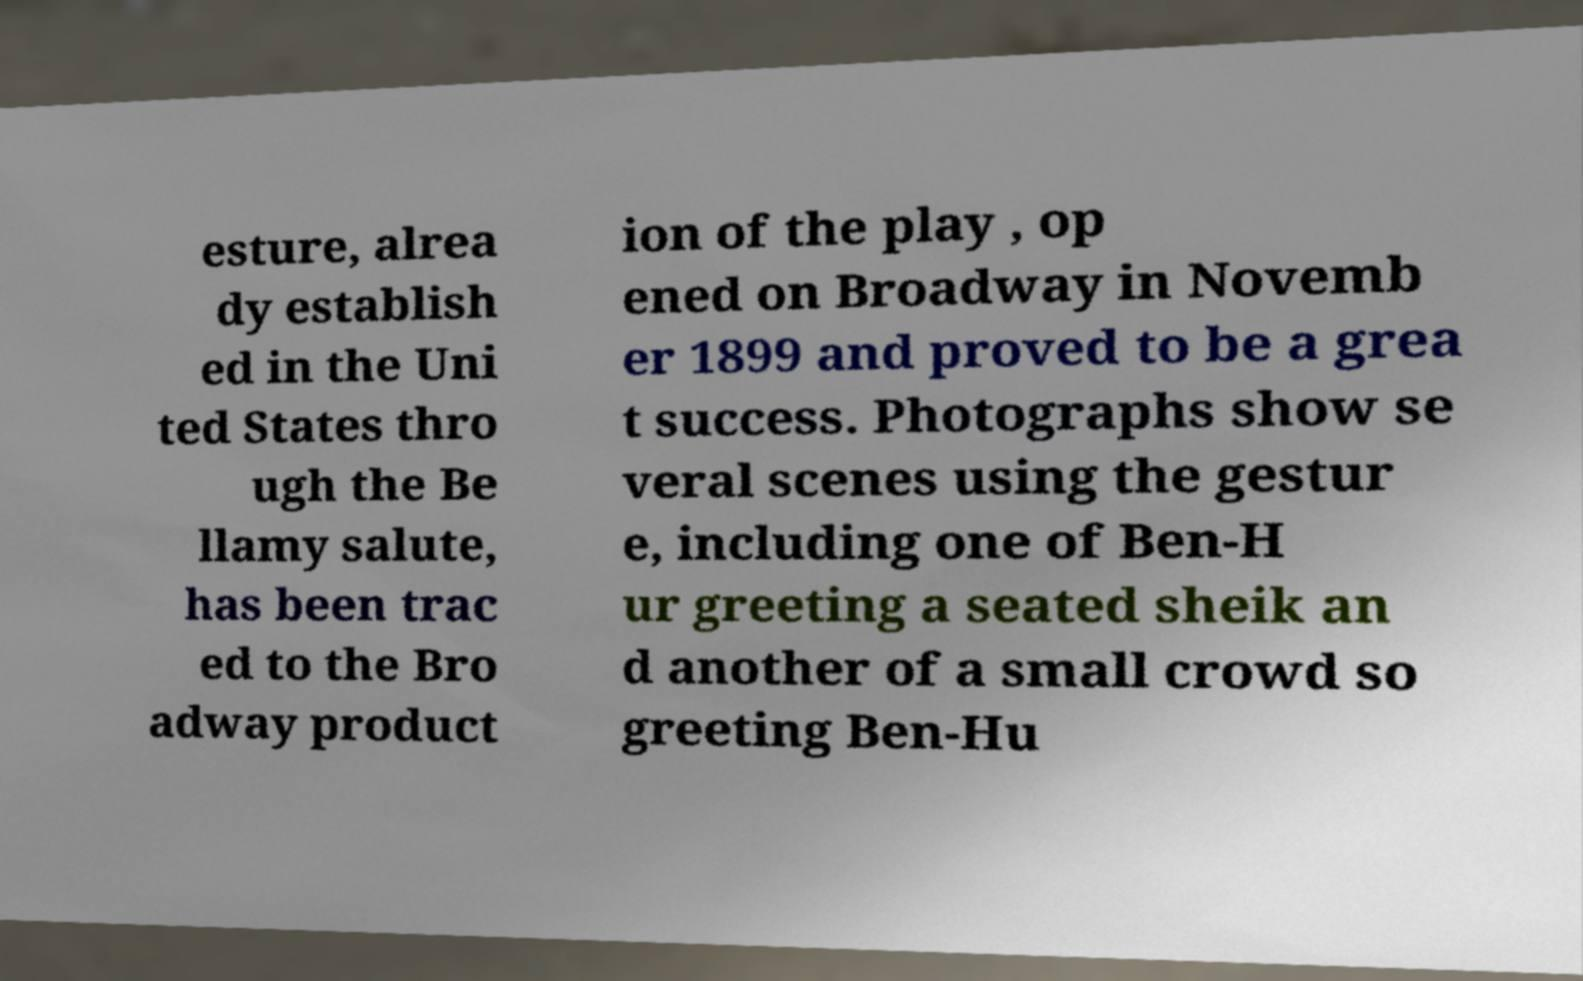What messages or text are displayed in this image? I need them in a readable, typed format. esture, alrea dy establish ed in the Uni ted States thro ugh the Be llamy salute, has been trac ed to the Bro adway product ion of the play , op ened on Broadway in Novemb er 1899 and proved to be a grea t success. Photographs show se veral scenes using the gestur e, including one of Ben-H ur greeting a seated sheik an d another of a small crowd so greeting Ben-Hu 